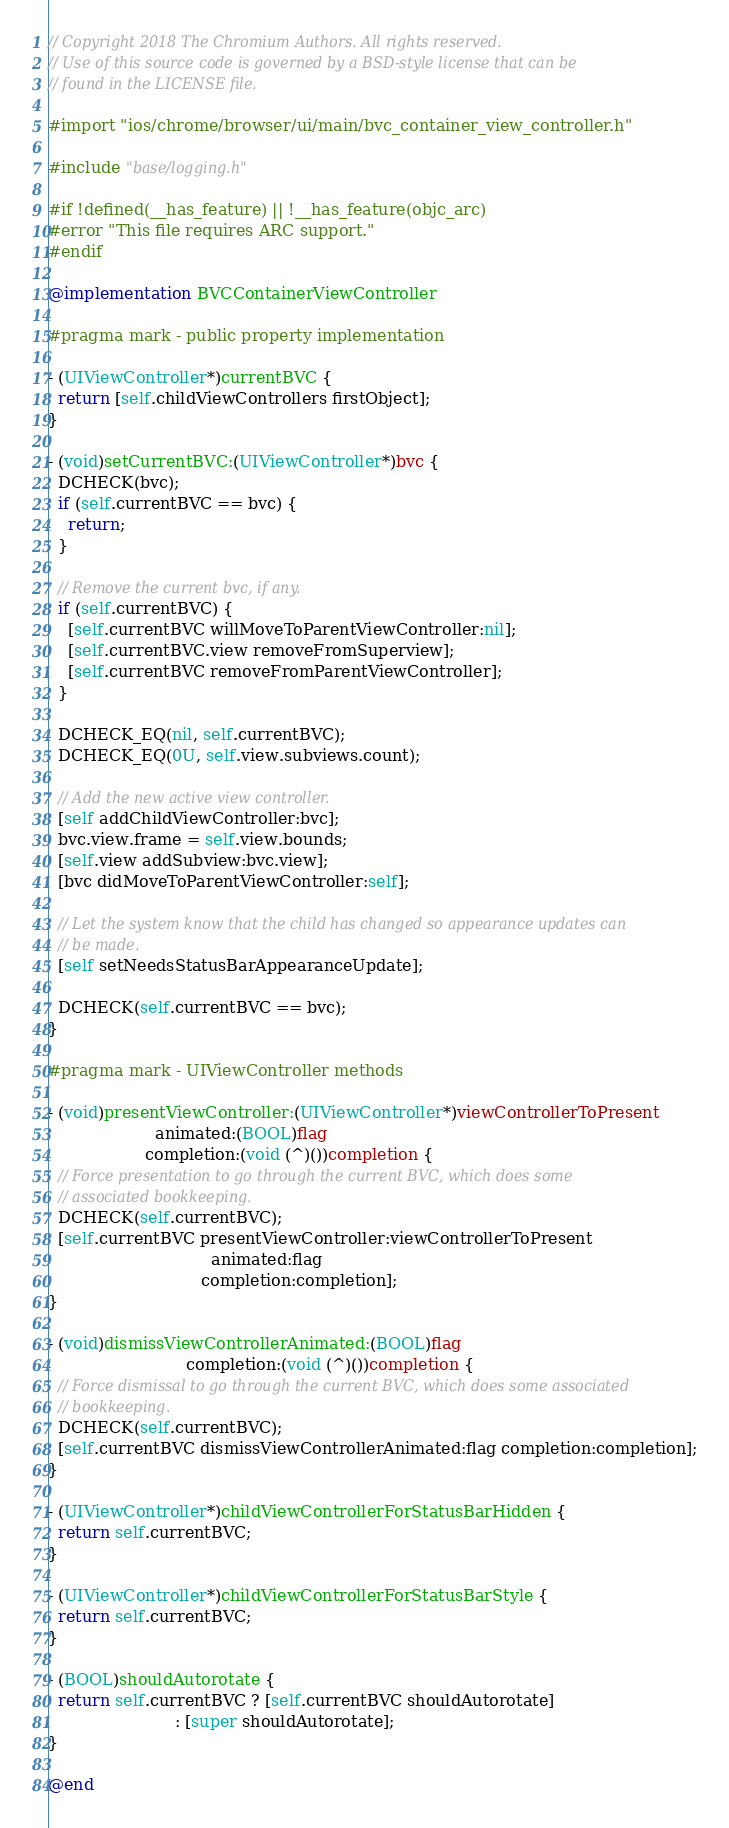<code> <loc_0><loc_0><loc_500><loc_500><_ObjectiveC_>// Copyright 2018 The Chromium Authors. All rights reserved.
// Use of this source code is governed by a BSD-style license that can be
// found in the LICENSE file.

#import "ios/chrome/browser/ui/main/bvc_container_view_controller.h"

#include "base/logging.h"

#if !defined(__has_feature) || !__has_feature(objc_arc)
#error "This file requires ARC support."
#endif

@implementation BVCContainerViewController

#pragma mark - public property implementation

- (UIViewController*)currentBVC {
  return [self.childViewControllers firstObject];
}

- (void)setCurrentBVC:(UIViewController*)bvc {
  DCHECK(bvc);
  if (self.currentBVC == bvc) {
    return;
  }

  // Remove the current bvc, if any.
  if (self.currentBVC) {
    [self.currentBVC willMoveToParentViewController:nil];
    [self.currentBVC.view removeFromSuperview];
    [self.currentBVC removeFromParentViewController];
  }

  DCHECK_EQ(nil, self.currentBVC);
  DCHECK_EQ(0U, self.view.subviews.count);

  // Add the new active view controller.
  [self addChildViewController:bvc];
  bvc.view.frame = self.view.bounds;
  [self.view addSubview:bvc.view];
  [bvc didMoveToParentViewController:self];

  // Let the system know that the child has changed so appearance updates can
  // be made.
  [self setNeedsStatusBarAppearanceUpdate];

  DCHECK(self.currentBVC == bvc);
}

#pragma mark - UIViewController methods

- (void)presentViewController:(UIViewController*)viewControllerToPresent
                     animated:(BOOL)flag
                   completion:(void (^)())completion {
  // Force presentation to go through the current BVC, which does some
  // associated bookkeeping.
  DCHECK(self.currentBVC);
  [self.currentBVC presentViewController:viewControllerToPresent
                                animated:flag
                              completion:completion];
}

- (void)dismissViewControllerAnimated:(BOOL)flag
                           completion:(void (^)())completion {
  // Force dismissal to go through the current BVC, which does some associated
  // bookkeeping.
  DCHECK(self.currentBVC);
  [self.currentBVC dismissViewControllerAnimated:flag completion:completion];
}

- (UIViewController*)childViewControllerForStatusBarHidden {
  return self.currentBVC;
}

- (UIViewController*)childViewControllerForStatusBarStyle {
  return self.currentBVC;
}

- (BOOL)shouldAutorotate {
  return self.currentBVC ? [self.currentBVC shouldAutorotate]
                         : [super shouldAutorotate];
}

@end
</code> 